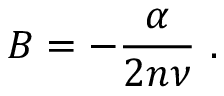<formula> <loc_0><loc_0><loc_500><loc_500>B = - \frac { \alpha } { 2 n \nu } .</formula> 